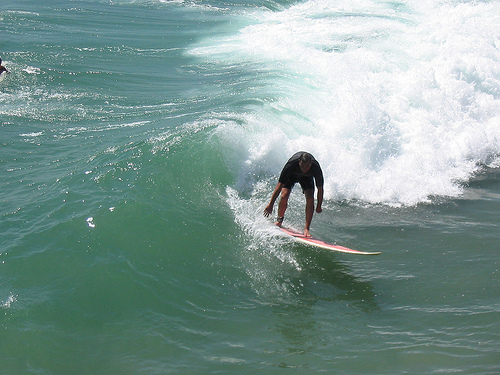Please provide a short description for this region: [0.16, 0.39, 0.35, 0.52]. This region shows small ripples in the water, likely caused by the movement of the waves and the surfer's impact. 